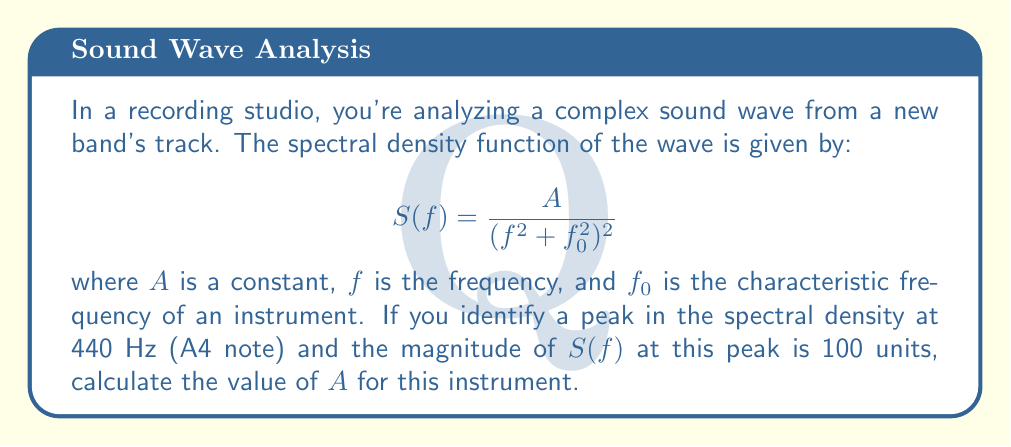Can you answer this question? To solve this problem, we'll follow these steps:

1) We know that the peak occurs at $f = 440$ Hz, which corresponds to the characteristic frequency $f_0$ of the instrument.

2) At this peak, $S(f) = 100$ units.

3) Substituting these values into the given equation:

   $$100 = \frac{A}{(440^2 + 440^2)^2}$$

4) Simplify the denominator:
   
   $$100 = \frac{A}{(2 \cdot 440^2)^2} = \frac{A}{4 \cdot 440^4}$$

5) Multiply both sides by $4 \cdot 440^4$:

   $$100 \cdot 4 \cdot 440^4 = A$$

6) Calculate:
   
   $$A = 100 \cdot 4 \cdot (440^4) = 400 \cdot 440^4 = 400 \cdot 37,478,400,000 = 14,991,360,000,000$$

Therefore, the value of $A$ for this instrument is 14,991,360,000,000 units.
Answer: $A = 14,991,360,000,000$ units 